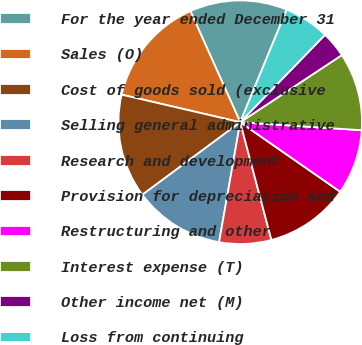Convert chart. <chart><loc_0><loc_0><loc_500><loc_500><pie_chart><fcel>For the year ended December 31<fcel>Sales (O)<fcel>Cost of goods sold (exclusive<fcel>Selling general administrative<fcel>Research and development<fcel>Provision for depreciation and<fcel>Restructuring and other<fcel>Interest expense (T)<fcel>Other income net (M)<fcel>Loss from continuing<nl><fcel>12.93%<fcel>14.66%<fcel>13.79%<fcel>12.07%<fcel>6.9%<fcel>11.21%<fcel>8.62%<fcel>10.34%<fcel>3.45%<fcel>6.03%<nl></chart> 